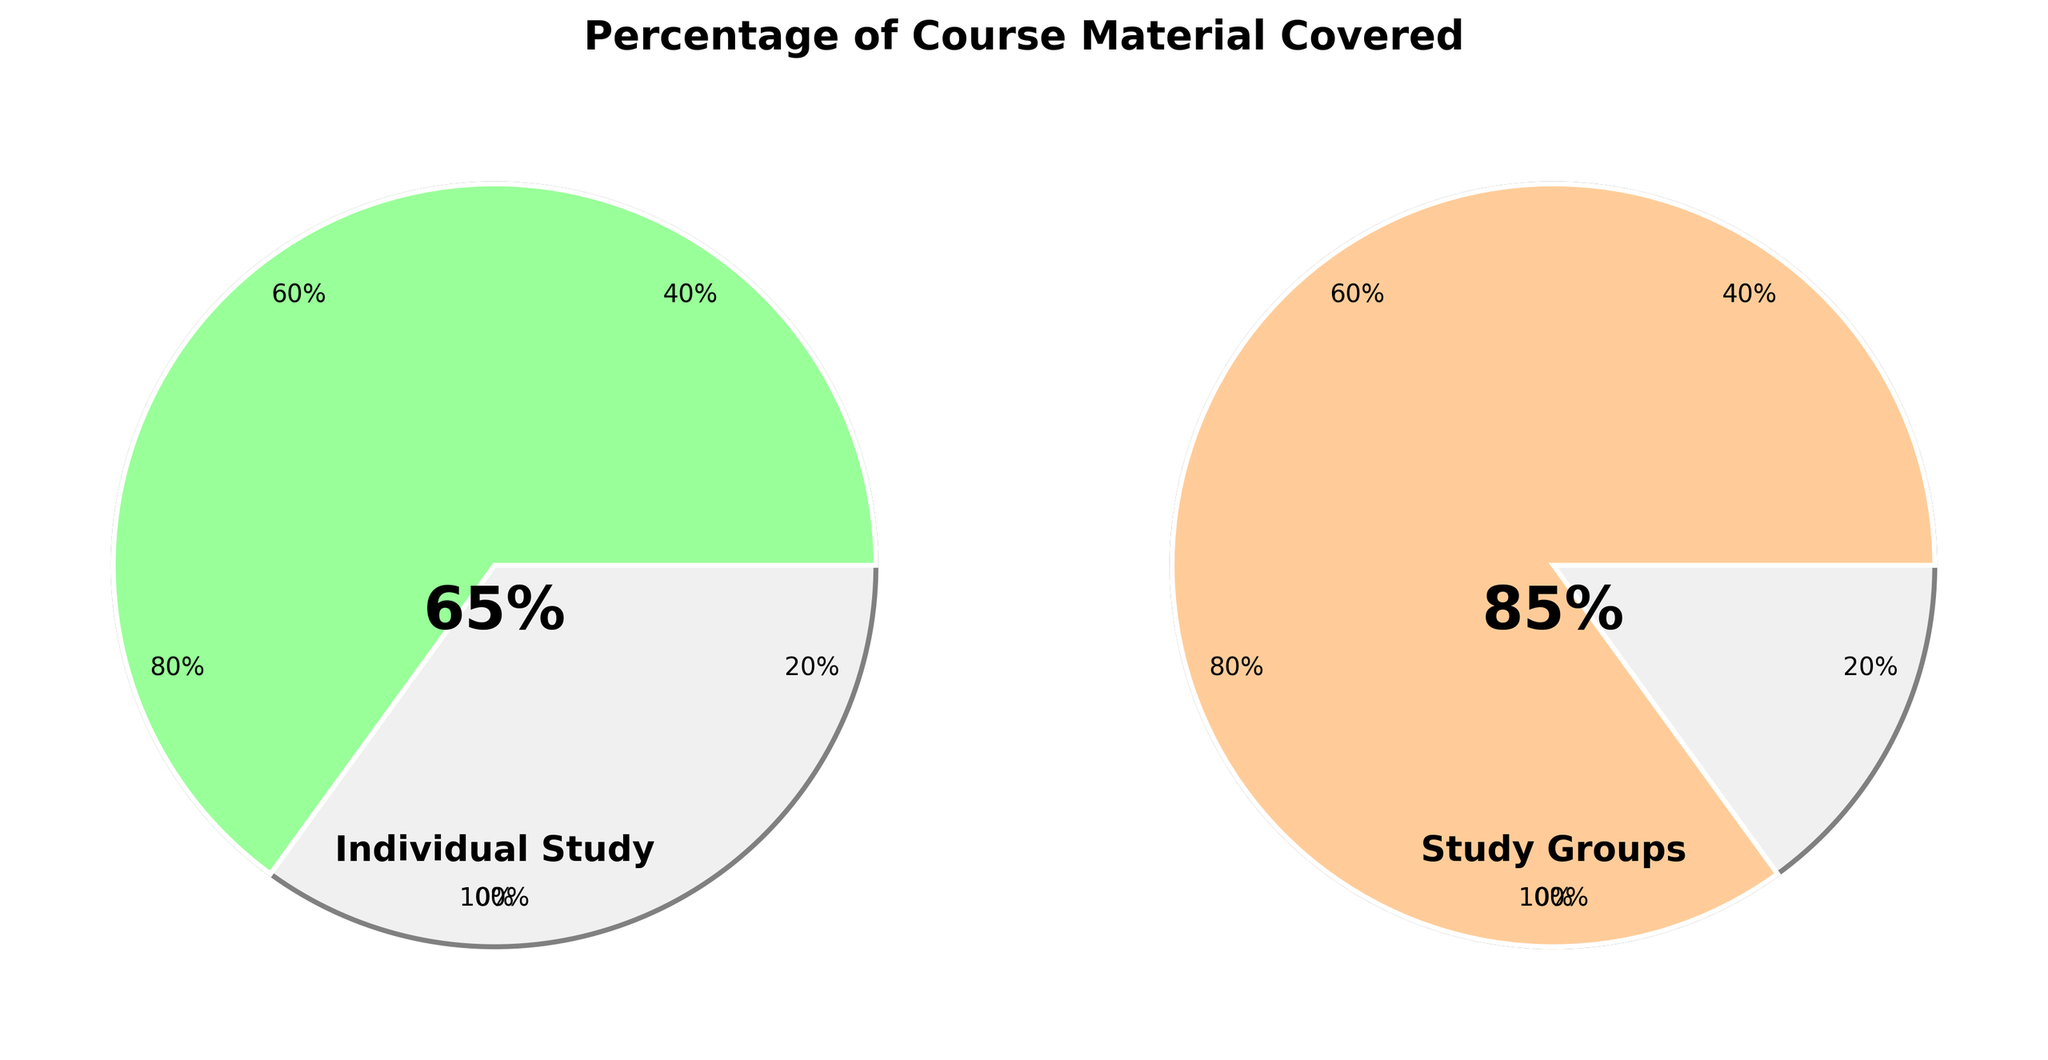What is the title of the figure? The title of the figure is prominently displayed at the top, reading "Percentage of Course Material Covered".
Answer: Percentage of Course Material Covered How much course material is covered during individual study? The gauge chart for individual study shows a marked area that reaches 65%. Additionally, the numerical value of 65% is also displayed near the center of the gauge.
Answer: 65% Which study method covers more course material? By comparing the two gauges, the gauge for "Study Groups" shows 85%, which is greater than the 65% shown for "Individual Study".
Answer: Study Groups What are the increments displayed around the gauges? Each gauge has ticks and labels at 20% increments, shown as 0%, 20%, 40%, 60%, 80%, and 100%.
Answer: 20% What percentage difference in content covered is there between study groups and individual study? The percentage for study groups is 85% and for individual study is 65%. Subtracting 65% from 85% results in a difference of 20%.
Answer: 20% What color represents the majority of the covered percentage in study groups? In the "Study Groups" gauge, the wedge corresponding to the 85% covered material is in a color gradient moving from the initial color through various shades, primarily blue around the 85% mark.
Answer: Blue What approximate angle does the "Study Groups" gauge cover from the center? Each percentage point corresponds to 3.6 degrees (since 360 degrees represent 100%). Therefore, 85% corresponds to 85 * 3.6 degrees, which is 306 degrees.
Answer: 306 degrees What is the central indication for both gauges? Both gauges have the percentage values representing the content covered, placed in the center of the gauge with bold text, displaying 65% and 85% respectively.
Answer: 65% and 85% What fraction of the material covered by the study group is not covered by individual study? To determine this, divide the percentage covered by individual study (65%) by the percentage covered by study groups (85%) to get the fraction: 65 / 85 ≈ 0.765. This means approximately 76.5%
Answer: 76.5% What is the primary question this figure aims to answer? The figure aims to visually compare the percentage of course material covered when studying individually versus in study groups, highlighting the relative effectiveness of these methods.
Answer: Effectiveness comparison 